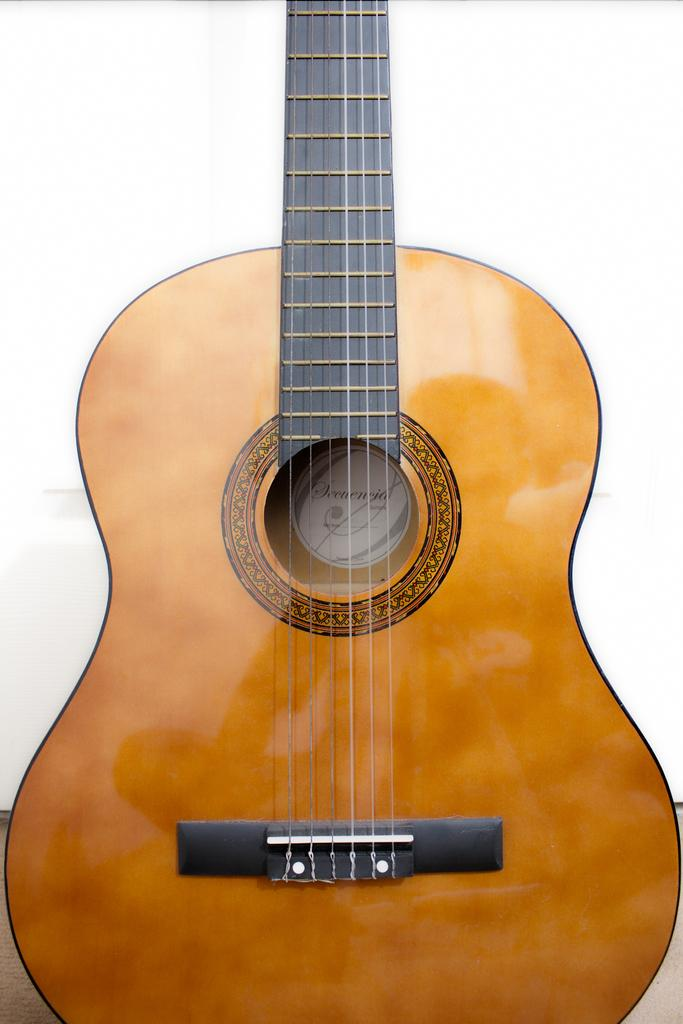What type of musical instrument is in the image? There is a yellow color guitar in the image. What feature of the guitar is mentioned in the facts? The guitar has strings. How is the guitar positioned in the image? The guitar is in a standing position. Is there a gold channel visible on the guitar in the image? There is no mention of a gold channel in the provided facts, and therefore it cannot be determined if one is present in the image. 